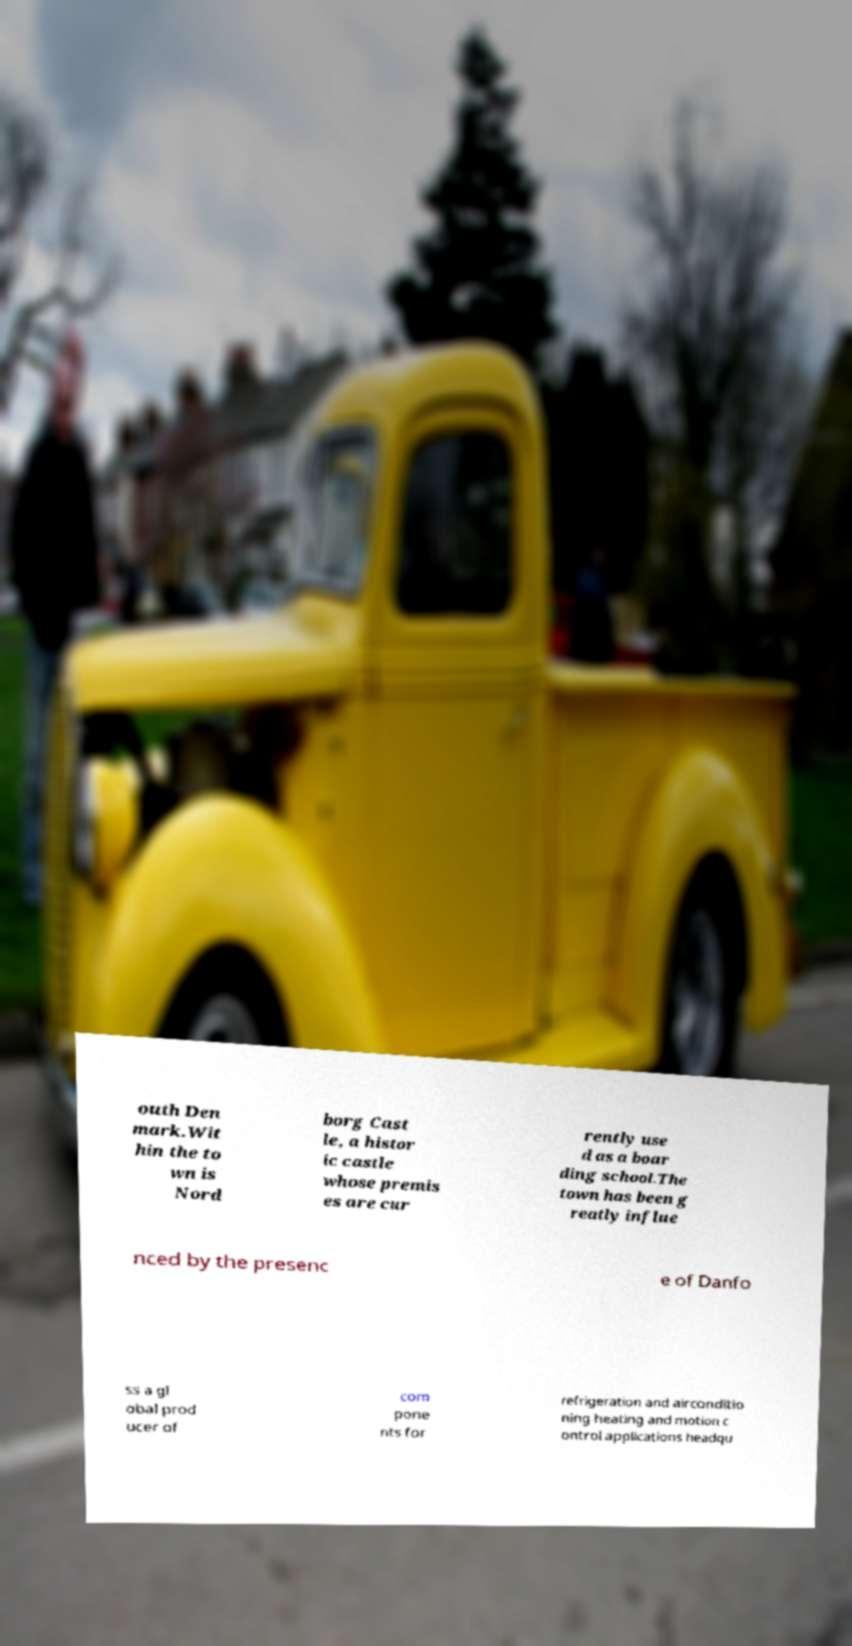Can you read and provide the text displayed in the image?This photo seems to have some interesting text. Can you extract and type it out for me? outh Den mark.Wit hin the to wn is Nord borg Cast le, a histor ic castle whose premis es are cur rently use d as a boar ding school.The town has been g reatly influe nced by the presenc e of Danfo ss a gl obal prod ucer of com pone nts for refrigeration and airconditio ning heating and motion c ontrol applications headqu 